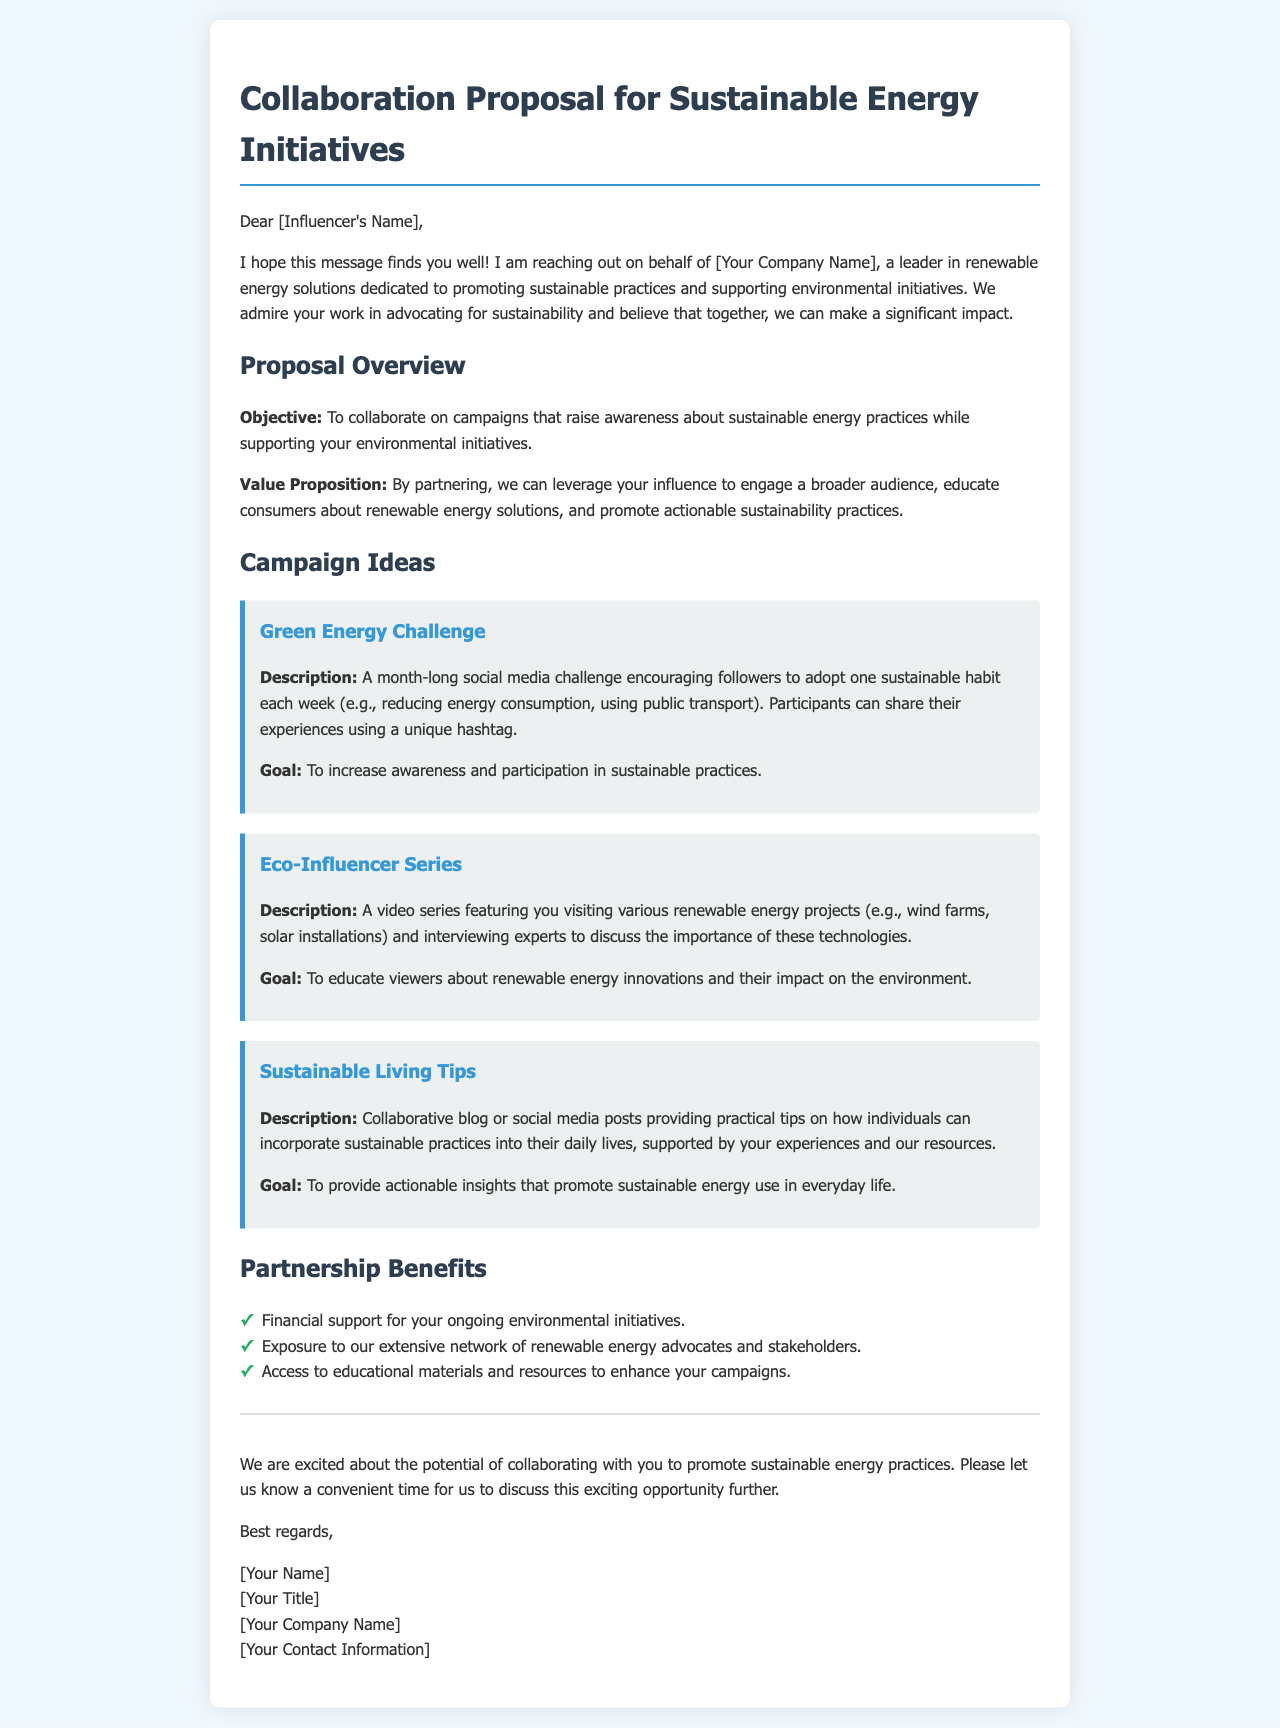What is the purpose of the collaboration? The purpose of the collaboration is outlined in the proposal, which states the objective of collaborating on campaigns that raise awareness about sustainable energy practices.
Answer: To collaborate on campaigns that raise awareness about sustainable energy practices Who is the proposal addressed to? The proposal is specifically directed at an influencer, as indicated by the salutation at the beginning of the document.
Answer: [Influencer's Name] What is the name of the company making the proposal? The company's name is mentioned in the introduction of the document as "[Your Company Name]."
Answer: [Your Company Name] How many campaign ideas are presented in the document? The document lists three distinct campaign ideas under the Campaign Ideas section.
Answer: 3 What is one benefit of partnership mentioned? One of the benefits of the partnership is described in the partnership benefits section.
Answer: Financial support for your ongoing environmental initiatives What is the goal of the "Green Energy Challenge"? The goal of the "Green Energy Challenge" is specified in the campaign description.
Answer: To increase awareness and participation in sustainable practices What type of content is suggested for the "Eco-Influencer Series"? The type of content for the "Eco-Influencer Series" involves video production focused on renewable energy projects.
Answer: Video series featuring you visiting various renewable energy projects What does the document request at the end? The closing paragraph of the document indicates that the sender is seeking a follow-up conversation regarding the proposal.
Answer: A convenient time for us to discuss this exciting opportunity further 